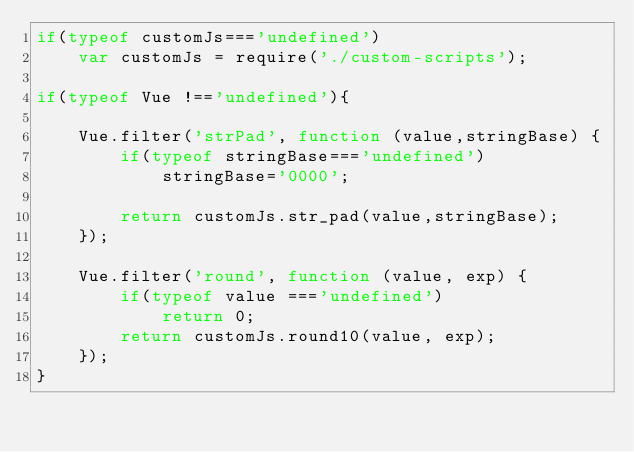Convert code to text. <code><loc_0><loc_0><loc_500><loc_500><_JavaScript_>if(typeof customJs==='undefined')
	var customJs = require('./custom-scripts');

if(typeof Vue !=='undefined'){

	Vue.filter('strPad', function (value,stringBase) {
		if(typeof stringBase==='undefined')
			stringBase='0000';

		return customJs.str_pad(value,stringBase);
	});

	Vue.filter('round', function (value, exp) {
		if(typeof value ==='undefined')
			return 0;
		return customJs.round10(value, exp);
	});
}</code> 